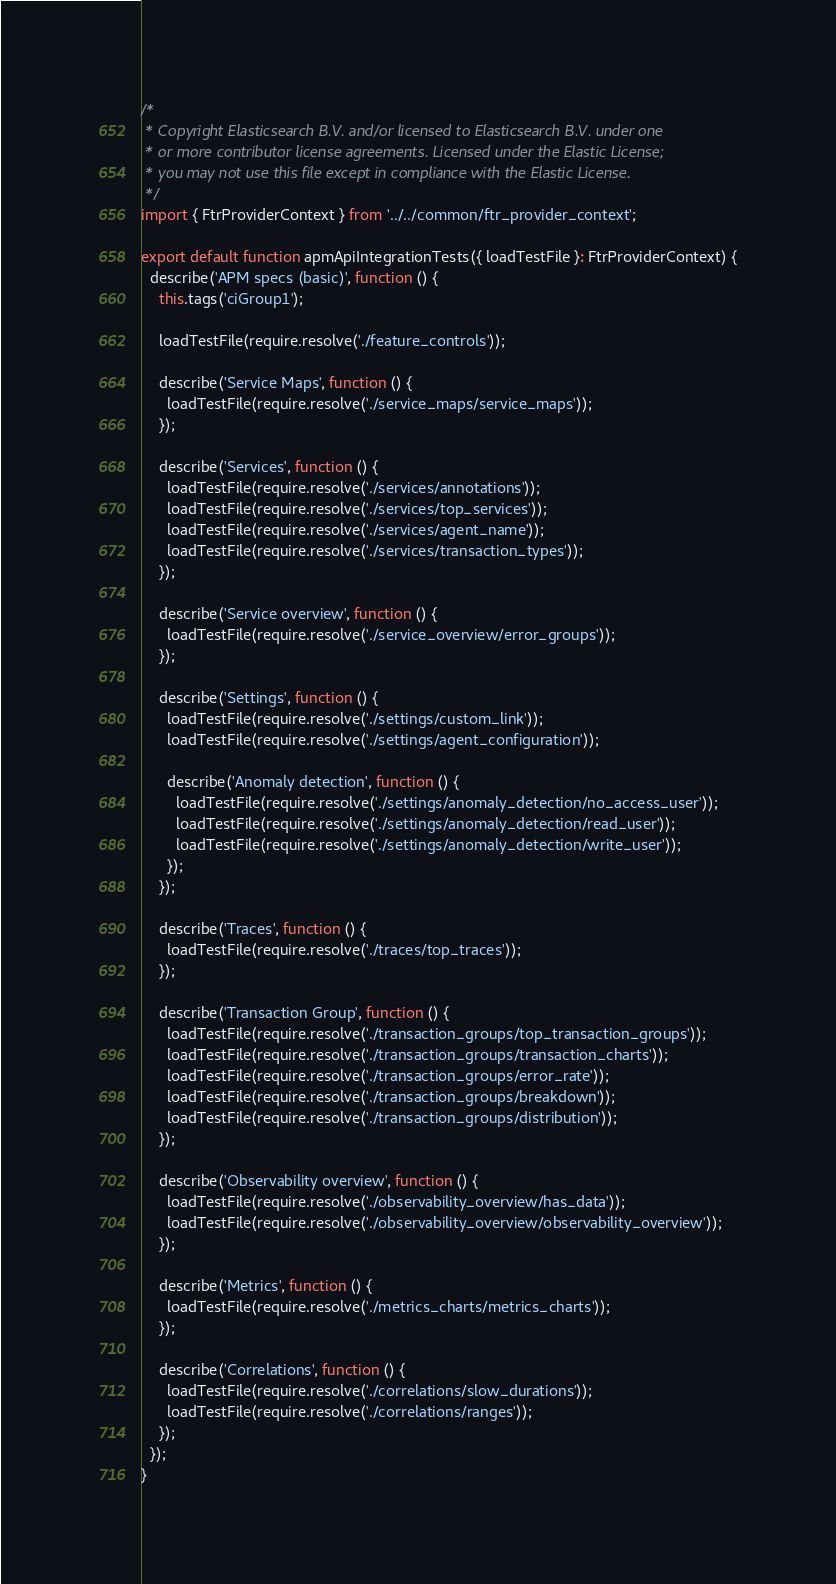<code> <loc_0><loc_0><loc_500><loc_500><_TypeScript_>/*
 * Copyright Elasticsearch B.V. and/or licensed to Elasticsearch B.V. under one
 * or more contributor license agreements. Licensed under the Elastic License;
 * you may not use this file except in compliance with the Elastic License.
 */
import { FtrProviderContext } from '../../common/ftr_provider_context';

export default function apmApiIntegrationTests({ loadTestFile }: FtrProviderContext) {
  describe('APM specs (basic)', function () {
    this.tags('ciGroup1');

    loadTestFile(require.resolve('./feature_controls'));

    describe('Service Maps', function () {
      loadTestFile(require.resolve('./service_maps/service_maps'));
    });

    describe('Services', function () {
      loadTestFile(require.resolve('./services/annotations'));
      loadTestFile(require.resolve('./services/top_services'));
      loadTestFile(require.resolve('./services/agent_name'));
      loadTestFile(require.resolve('./services/transaction_types'));
    });

    describe('Service overview', function () {
      loadTestFile(require.resolve('./service_overview/error_groups'));
    });

    describe('Settings', function () {
      loadTestFile(require.resolve('./settings/custom_link'));
      loadTestFile(require.resolve('./settings/agent_configuration'));

      describe('Anomaly detection', function () {
        loadTestFile(require.resolve('./settings/anomaly_detection/no_access_user'));
        loadTestFile(require.resolve('./settings/anomaly_detection/read_user'));
        loadTestFile(require.resolve('./settings/anomaly_detection/write_user'));
      });
    });

    describe('Traces', function () {
      loadTestFile(require.resolve('./traces/top_traces'));
    });

    describe('Transaction Group', function () {
      loadTestFile(require.resolve('./transaction_groups/top_transaction_groups'));
      loadTestFile(require.resolve('./transaction_groups/transaction_charts'));
      loadTestFile(require.resolve('./transaction_groups/error_rate'));
      loadTestFile(require.resolve('./transaction_groups/breakdown'));
      loadTestFile(require.resolve('./transaction_groups/distribution'));
    });

    describe('Observability overview', function () {
      loadTestFile(require.resolve('./observability_overview/has_data'));
      loadTestFile(require.resolve('./observability_overview/observability_overview'));
    });

    describe('Metrics', function () {
      loadTestFile(require.resolve('./metrics_charts/metrics_charts'));
    });

    describe('Correlations', function () {
      loadTestFile(require.resolve('./correlations/slow_durations'));
      loadTestFile(require.resolve('./correlations/ranges'));
    });
  });
}
</code> 